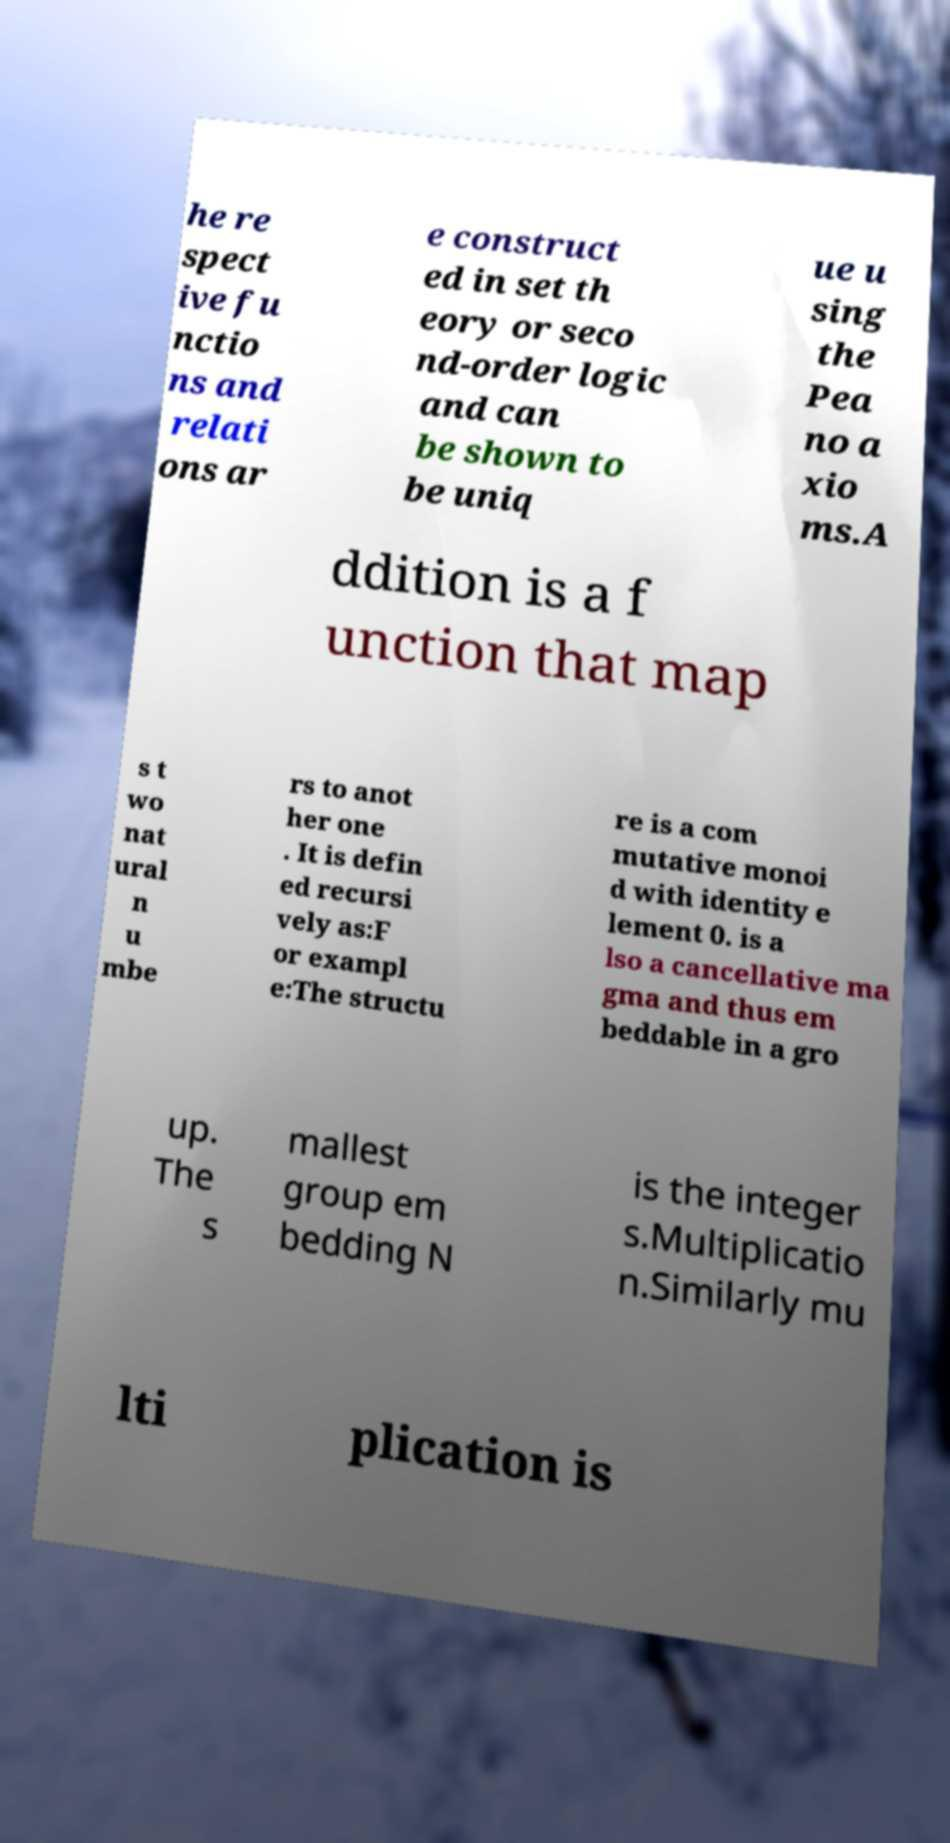I need the written content from this picture converted into text. Can you do that? he re spect ive fu nctio ns and relati ons ar e construct ed in set th eory or seco nd-order logic and can be shown to be uniq ue u sing the Pea no a xio ms.A ddition is a f unction that map s t wo nat ural n u mbe rs to anot her one . It is defin ed recursi vely as:F or exampl e:The structu re is a com mutative monoi d with identity e lement 0. is a lso a cancellative ma gma and thus em beddable in a gro up. The s mallest group em bedding N is the integer s.Multiplicatio n.Similarly mu lti plication is 